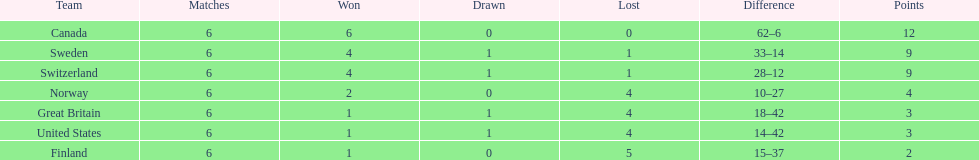Which country performed better during the 1951 world ice hockey championships, switzerland or great britain? Switzerland. Parse the table in full. {'header': ['Team', 'Matches', 'Won', 'Drawn', 'Lost', 'Difference', 'Points'], 'rows': [['Canada', '6', '6', '0', '0', '62–6', '12'], ['Sweden', '6', '4', '1', '1', '33–14', '9'], ['Switzerland', '6', '4', '1', '1', '28–12', '9'], ['Norway', '6', '2', '0', '4', '10–27', '4'], ['Great Britain', '6', '1', '1', '4', '18–42', '3'], ['United States', '6', '1', '1', '4', '14–42', '3'], ['Finland', '6', '1', '0', '5', '15–37', '2']]} 